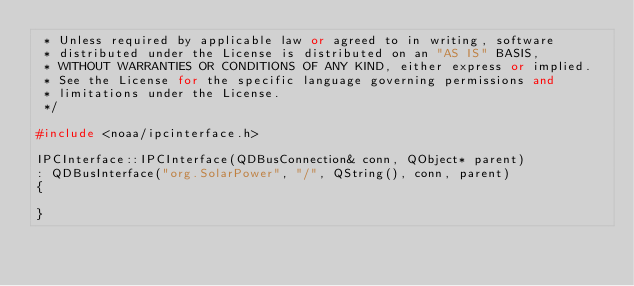Convert code to text. <code><loc_0><loc_0><loc_500><loc_500><_C++_> * Unless required by applicable law or agreed to in writing, software
 * distributed under the License is distributed on an "AS IS" BASIS,
 * WITHOUT WARRANTIES OR CONDITIONS OF ANY KIND, either express or implied.
 * See the License for the specific language governing permissions and
 * limitations under the License.
 */

#include <noaa/ipcinterface.h>

IPCInterface::IPCInterface(QDBusConnection& conn, QObject* parent)
: QDBusInterface("org.SolarPower", "/", QString(), conn, parent)
{

}
</code> 